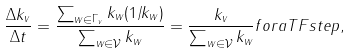<formula> <loc_0><loc_0><loc_500><loc_500>\frac { \Delta k _ { v } } { \Delta t } = \frac { \sum _ { w \in \Gamma _ { v } } k _ { w } ( 1 / k _ { w } ) } { \sum _ { w \in \mathcal { V } } k _ { w } } = \frac { k _ { v } } { \sum _ { w \in \mathcal { V } } k _ { w } } f o r a T F s t e p ,</formula> 